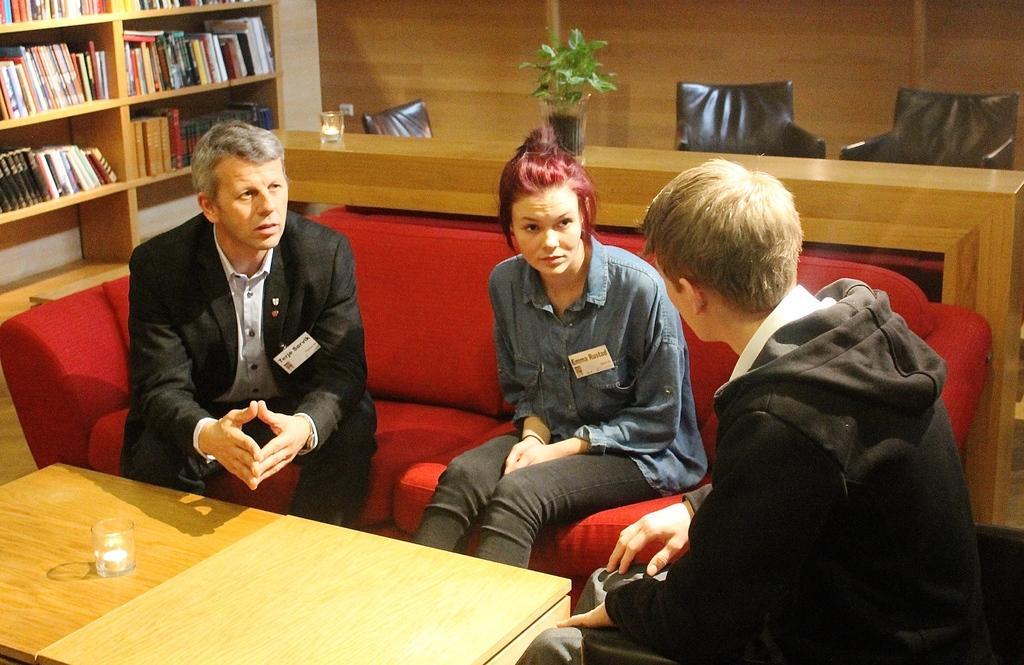How would you summarize this image in a sentence or two? In this image i can see there are three people sitting on the sofa, among them one is a women and two are men. Behind the women there is a plant on the table and left side of the image we can see a shelf with few books. In front of these people there is a table and on the table we can see a glass. 